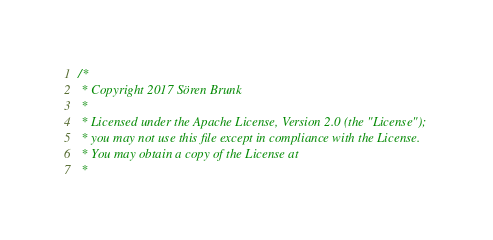<code> <loc_0><loc_0><loc_500><loc_500><_Scala_>/*
 * Copyright 2017 Sören Brunk
 *
 * Licensed under the Apache License, Version 2.0 (the "License");
 * you may not use this file except in compliance with the License.
 * You may obtain a copy of the License at
 *</code> 